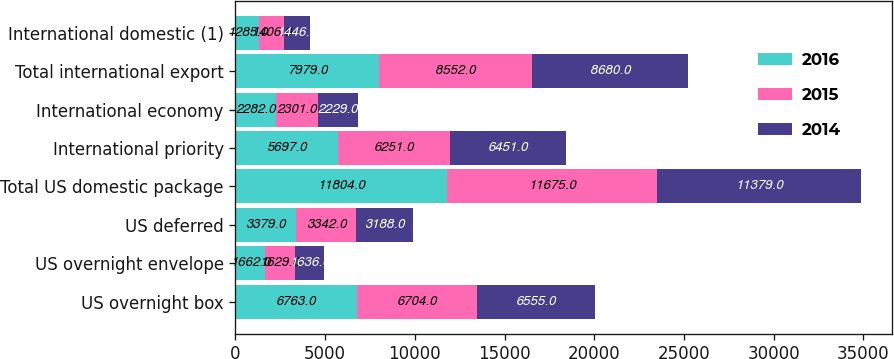Convert chart to OTSL. <chart><loc_0><loc_0><loc_500><loc_500><stacked_bar_chart><ecel><fcel>US overnight box<fcel>US overnight envelope<fcel>US deferred<fcel>Total US domestic package<fcel>International priority<fcel>International economy<fcel>Total international export<fcel>International domestic (1)<nl><fcel>2016<fcel>6763<fcel>1662<fcel>3379<fcel>11804<fcel>5697<fcel>2282<fcel>7979<fcel>1285<nl><fcel>2015<fcel>6704<fcel>1629<fcel>3342<fcel>11675<fcel>6251<fcel>2301<fcel>8552<fcel>1406<nl><fcel>2014<fcel>6555<fcel>1636<fcel>3188<fcel>11379<fcel>6451<fcel>2229<fcel>8680<fcel>1446<nl></chart> 